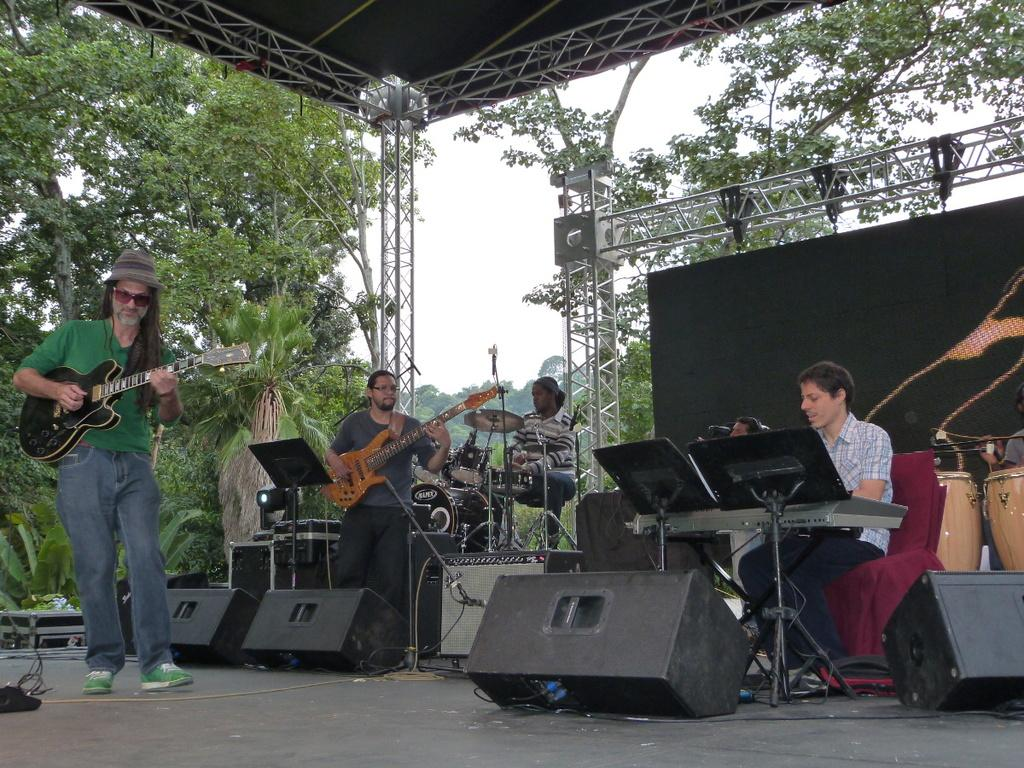What are the persons in the image doing? The persons in the image are playing musical instruments. Where are the persons playing the instruments located? The persons are aboard a structure or vehicle. What can be seen in the image that might be used for safety or support? There is a railing in the image. What type of natural element is visible in the image? There is a tree visible in the image. What is visible in the background of the image? The sky is visible in the image. What type of clock is visible in the image? There is no clock present in the image. Is there a birthday celebration happening in the image? There is no indication of a birthday celebration in the image. 